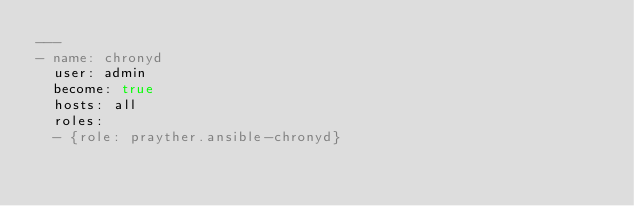Convert code to text. <code><loc_0><loc_0><loc_500><loc_500><_YAML_>---
- name: chronyd
  user: admin
  become: true
  hosts: all
  roles:
  - {role: prayther.ansible-chronyd}
</code> 